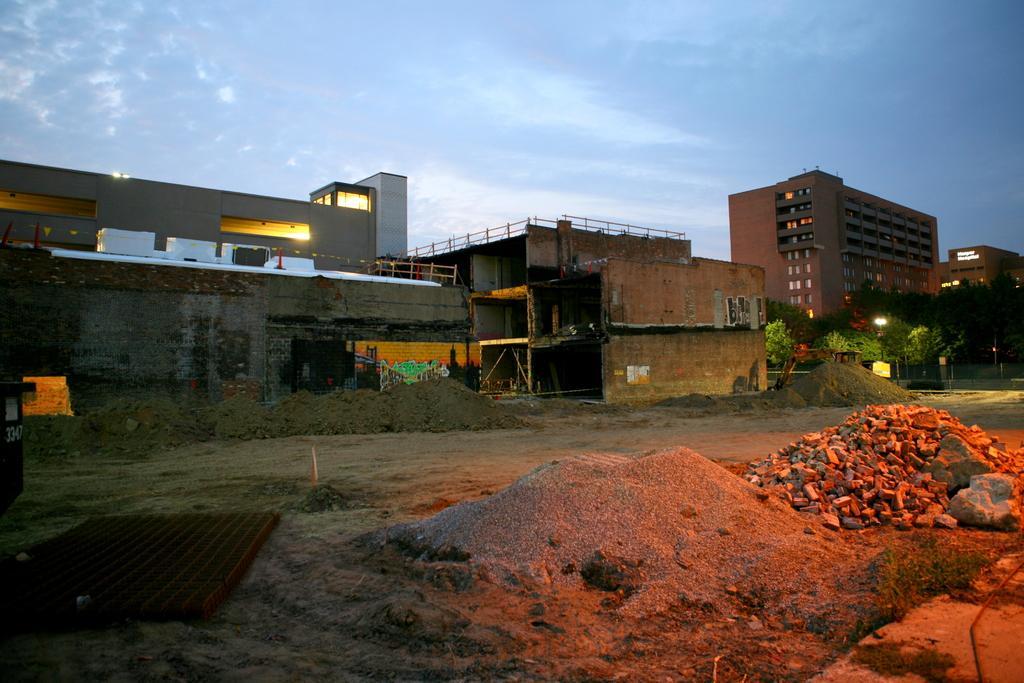Could you give a brief overview of what you see in this image? In this picture we can see few buildings, lights, trees and a vehicle, on the right side of the image we can find few rocks. 